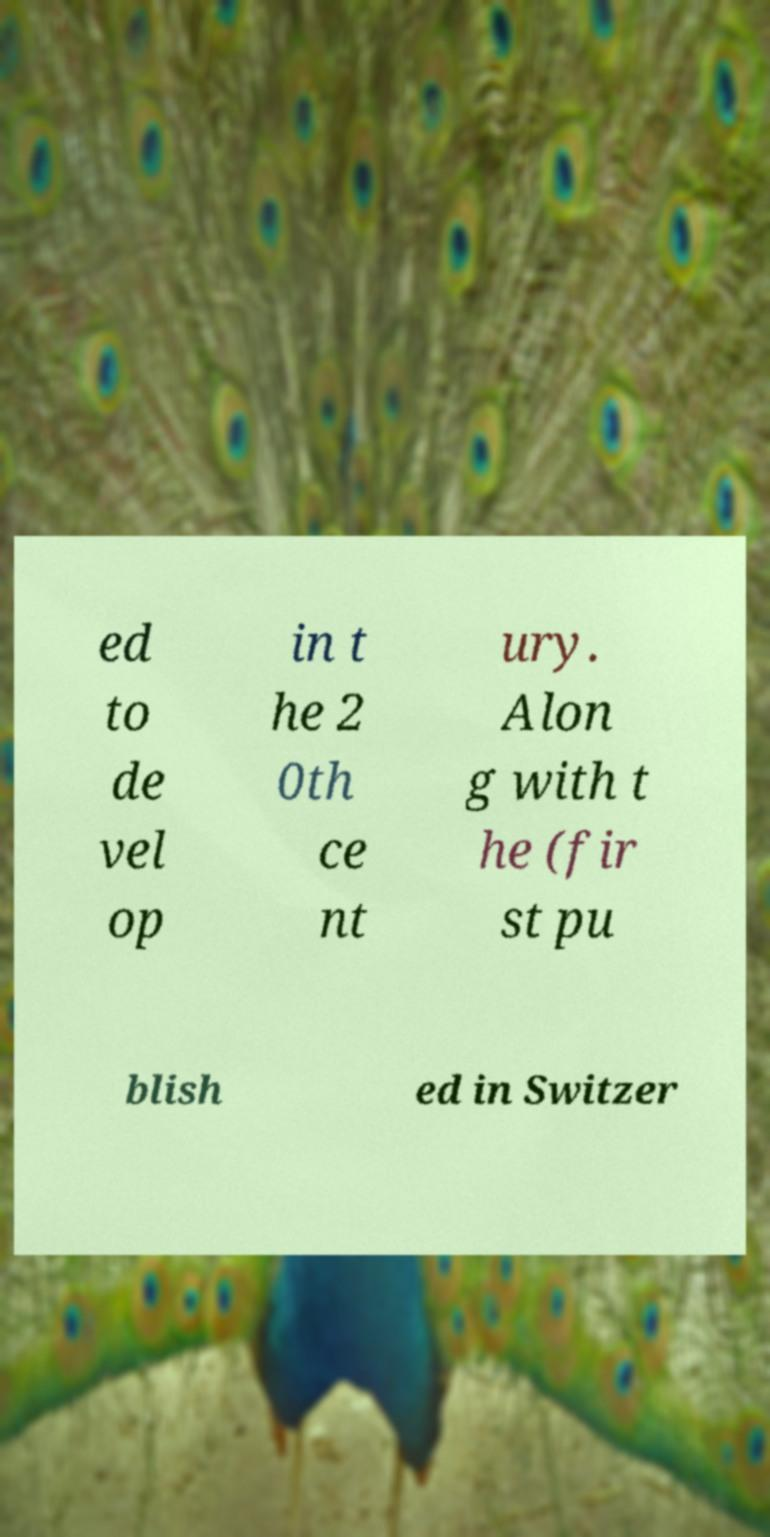Can you read and provide the text displayed in the image?This photo seems to have some interesting text. Can you extract and type it out for me? ed to de vel op in t he 2 0th ce nt ury. Alon g with t he (fir st pu blish ed in Switzer 